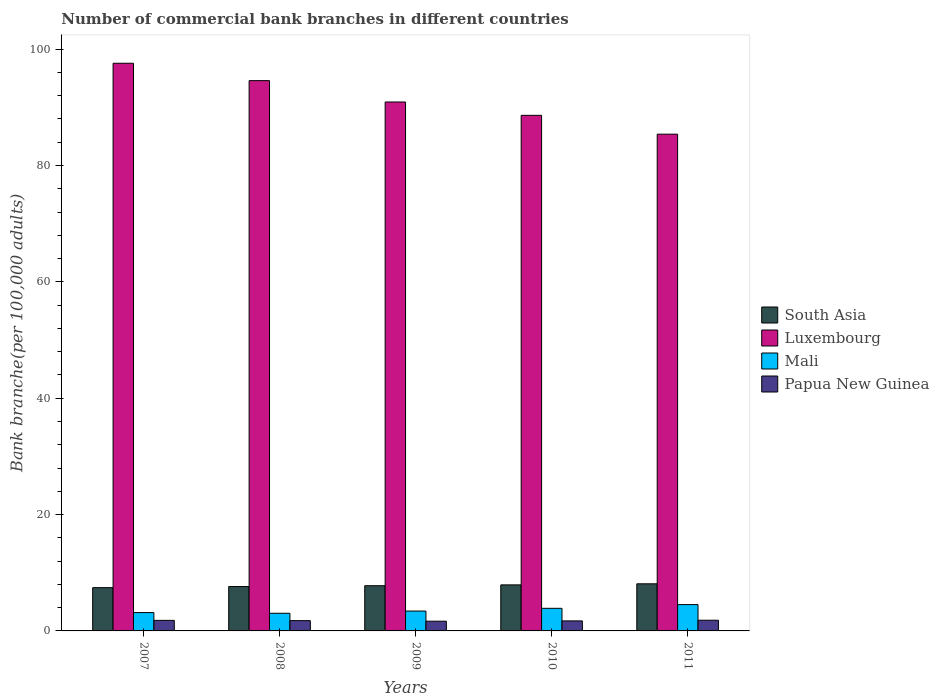How many groups of bars are there?
Make the answer very short. 5. Are the number of bars on each tick of the X-axis equal?
Your answer should be compact. Yes. How many bars are there on the 4th tick from the left?
Ensure brevity in your answer.  4. What is the number of commercial bank branches in Papua New Guinea in 2009?
Provide a succinct answer. 1.67. Across all years, what is the maximum number of commercial bank branches in Mali?
Provide a succinct answer. 4.52. Across all years, what is the minimum number of commercial bank branches in Mali?
Your response must be concise. 3.03. In which year was the number of commercial bank branches in Papua New Guinea maximum?
Your answer should be compact. 2011. In which year was the number of commercial bank branches in Mali minimum?
Make the answer very short. 2008. What is the total number of commercial bank branches in Mali in the graph?
Offer a very short reply. 18.01. What is the difference between the number of commercial bank branches in South Asia in 2008 and that in 2010?
Provide a succinct answer. -0.29. What is the difference between the number of commercial bank branches in Papua New Guinea in 2007 and the number of commercial bank branches in Mali in 2008?
Offer a very short reply. -1.22. What is the average number of commercial bank branches in Luxembourg per year?
Offer a terse response. 91.42. In the year 2009, what is the difference between the number of commercial bank branches in South Asia and number of commercial bank branches in Mali?
Keep it short and to the point. 4.36. In how many years, is the number of commercial bank branches in Luxembourg greater than 52?
Your answer should be compact. 5. What is the ratio of the number of commercial bank branches in South Asia in 2007 to that in 2009?
Your response must be concise. 0.96. Is the difference between the number of commercial bank branches in South Asia in 2007 and 2010 greater than the difference between the number of commercial bank branches in Mali in 2007 and 2010?
Keep it short and to the point. Yes. What is the difference between the highest and the second highest number of commercial bank branches in Luxembourg?
Offer a very short reply. 2.99. What is the difference between the highest and the lowest number of commercial bank branches in South Asia?
Ensure brevity in your answer.  0.66. What does the 4th bar from the left in 2008 represents?
Make the answer very short. Papua New Guinea. What does the 3rd bar from the right in 2010 represents?
Ensure brevity in your answer.  Luxembourg. How many bars are there?
Provide a short and direct response. 20. Does the graph contain any zero values?
Give a very brief answer. No. How are the legend labels stacked?
Provide a short and direct response. Vertical. What is the title of the graph?
Give a very brief answer. Number of commercial bank branches in different countries. What is the label or title of the X-axis?
Offer a terse response. Years. What is the label or title of the Y-axis?
Ensure brevity in your answer.  Bank branche(per 100,0 adults). What is the Bank branche(per 100,000 adults) in South Asia in 2007?
Provide a succinct answer. 7.44. What is the Bank branche(per 100,000 adults) of Luxembourg in 2007?
Ensure brevity in your answer.  97.57. What is the Bank branche(per 100,000 adults) in Mali in 2007?
Keep it short and to the point. 3.15. What is the Bank branche(per 100,000 adults) of Papua New Guinea in 2007?
Your answer should be compact. 1.81. What is the Bank branche(per 100,000 adults) in South Asia in 2008?
Your answer should be very brief. 7.63. What is the Bank branche(per 100,000 adults) in Luxembourg in 2008?
Provide a short and direct response. 94.59. What is the Bank branche(per 100,000 adults) in Mali in 2008?
Offer a terse response. 3.03. What is the Bank branche(per 100,000 adults) in Papua New Guinea in 2008?
Make the answer very short. 1.77. What is the Bank branche(per 100,000 adults) in South Asia in 2009?
Your response must be concise. 7.77. What is the Bank branche(per 100,000 adults) in Luxembourg in 2009?
Provide a short and direct response. 90.92. What is the Bank branche(per 100,000 adults) of Mali in 2009?
Make the answer very short. 3.42. What is the Bank branche(per 100,000 adults) in Papua New Guinea in 2009?
Ensure brevity in your answer.  1.67. What is the Bank branche(per 100,000 adults) in South Asia in 2010?
Make the answer very short. 7.91. What is the Bank branche(per 100,000 adults) in Luxembourg in 2010?
Give a very brief answer. 88.62. What is the Bank branche(per 100,000 adults) of Mali in 2010?
Your answer should be very brief. 3.88. What is the Bank branche(per 100,000 adults) of Papua New Guinea in 2010?
Give a very brief answer. 1.72. What is the Bank branche(per 100,000 adults) in South Asia in 2011?
Give a very brief answer. 8.1. What is the Bank branche(per 100,000 adults) of Luxembourg in 2011?
Make the answer very short. 85.38. What is the Bank branche(per 100,000 adults) of Mali in 2011?
Your answer should be compact. 4.52. What is the Bank branche(per 100,000 adults) of Papua New Guinea in 2011?
Your answer should be very brief. 1.84. Across all years, what is the maximum Bank branche(per 100,000 adults) in South Asia?
Make the answer very short. 8.1. Across all years, what is the maximum Bank branche(per 100,000 adults) in Luxembourg?
Offer a terse response. 97.57. Across all years, what is the maximum Bank branche(per 100,000 adults) of Mali?
Ensure brevity in your answer.  4.52. Across all years, what is the maximum Bank branche(per 100,000 adults) in Papua New Guinea?
Your response must be concise. 1.84. Across all years, what is the minimum Bank branche(per 100,000 adults) of South Asia?
Your answer should be compact. 7.44. Across all years, what is the minimum Bank branche(per 100,000 adults) of Luxembourg?
Give a very brief answer. 85.38. Across all years, what is the minimum Bank branche(per 100,000 adults) of Mali?
Provide a succinct answer. 3.03. Across all years, what is the minimum Bank branche(per 100,000 adults) of Papua New Guinea?
Make the answer very short. 1.67. What is the total Bank branche(per 100,000 adults) of South Asia in the graph?
Keep it short and to the point. 38.85. What is the total Bank branche(per 100,000 adults) of Luxembourg in the graph?
Give a very brief answer. 457.08. What is the total Bank branche(per 100,000 adults) in Mali in the graph?
Your response must be concise. 18.01. What is the total Bank branche(per 100,000 adults) of Papua New Guinea in the graph?
Your answer should be compact. 8.82. What is the difference between the Bank branche(per 100,000 adults) of South Asia in 2007 and that in 2008?
Your answer should be compact. -0.19. What is the difference between the Bank branche(per 100,000 adults) in Luxembourg in 2007 and that in 2008?
Your answer should be very brief. 2.99. What is the difference between the Bank branche(per 100,000 adults) of Mali in 2007 and that in 2008?
Make the answer very short. 0.12. What is the difference between the Bank branche(per 100,000 adults) of Papua New Guinea in 2007 and that in 2008?
Offer a terse response. 0.05. What is the difference between the Bank branche(per 100,000 adults) in South Asia in 2007 and that in 2009?
Keep it short and to the point. -0.33. What is the difference between the Bank branche(per 100,000 adults) of Luxembourg in 2007 and that in 2009?
Offer a terse response. 6.66. What is the difference between the Bank branche(per 100,000 adults) in Mali in 2007 and that in 2009?
Make the answer very short. -0.26. What is the difference between the Bank branche(per 100,000 adults) in Papua New Guinea in 2007 and that in 2009?
Provide a succinct answer. 0.14. What is the difference between the Bank branche(per 100,000 adults) of South Asia in 2007 and that in 2010?
Make the answer very short. -0.48. What is the difference between the Bank branche(per 100,000 adults) in Luxembourg in 2007 and that in 2010?
Ensure brevity in your answer.  8.95. What is the difference between the Bank branche(per 100,000 adults) of Mali in 2007 and that in 2010?
Your answer should be compact. -0.73. What is the difference between the Bank branche(per 100,000 adults) of Papua New Guinea in 2007 and that in 2010?
Your response must be concise. 0.09. What is the difference between the Bank branche(per 100,000 adults) of South Asia in 2007 and that in 2011?
Offer a very short reply. -0.66. What is the difference between the Bank branche(per 100,000 adults) of Luxembourg in 2007 and that in 2011?
Ensure brevity in your answer.  12.19. What is the difference between the Bank branche(per 100,000 adults) of Mali in 2007 and that in 2011?
Offer a very short reply. -1.37. What is the difference between the Bank branche(per 100,000 adults) in Papua New Guinea in 2007 and that in 2011?
Provide a short and direct response. -0.02. What is the difference between the Bank branche(per 100,000 adults) in South Asia in 2008 and that in 2009?
Provide a short and direct response. -0.14. What is the difference between the Bank branche(per 100,000 adults) of Luxembourg in 2008 and that in 2009?
Your answer should be very brief. 3.67. What is the difference between the Bank branche(per 100,000 adults) of Mali in 2008 and that in 2009?
Ensure brevity in your answer.  -0.38. What is the difference between the Bank branche(per 100,000 adults) of Papua New Guinea in 2008 and that in 2009?
Ensure brevity in your answer.  0.1. What is the difference between the Bank branche(per 100,000 adults) in South Asia in 2008 and that in 2010?
Offer a very short reply. -0.29. What is the difference between the Bank branche(per 100,000 adults) of Luxembourg in 2008 and that in 2010?
Offer a very short reply. 5.97. What is the difference between the Bank branche(per 100,000 adults) of Mali in 2008 and that in 2010?
Offer a terse response. -0.85. What is the difference between the Bank branche(per 100,000 adults) in Papua New Guinea in 2008 and that in 2010?
Ensure brevity in your answer.  0.04. What is the difference between the Bank branche(per 100,000 adults) of South Asia in 2008 and that in 2011?
Provide a succinct answer. -0.47. What is the difference between the Bank branche(per 100,000 adults) in Luxembourg in 2008 and that in 2011?
Ensure brevity in your answer.  9.2. What is the difference between the Bank branche(per 100,000 adults) of Mali in 2008 and that in 2011?
Your answer should be very brief. -1.49. What is the difference between the Bank branche(per 100,000 adults) of Papua New Guinea in 2008 and that in 2011?
Offer a very short reply. -0.07. What is the difference between the Bank branche(per 100,000 adults) in South Asia in 2009 and that in 2010?
Your answer should be compact. -0.14. What is the difference between the Bank branche(per 100,000 adults) in Luxembourg in 2009 and that in 2010?
Your response must be concise. 2.29. What is the difference between the Bank branche(per 100,000 adults) in Mali in 2009 and that in 2010?
Ensure brevity in your answer.  -0.47. What is the difference between the Bank branche(per 100,000 adults) of Papua New Guinea in 2009 and that in 2010?
Make the answer very short. -0.05. What is the difference between the Bank branche(per 100,000 adults) of South Asia in 2009 and that in 2011?
Make the answer very short. -0.33. What is the difference between the Bank branche(per 100,000 adults) of Luxembourg in 2009 and that in 2011?
Offer a very short reply. 5.53. What is the difference between the Bank branche(per 100,000 adults) in Mali in 2009 and that in 2011?
Your response must be concise. -1.11. What is the difference between the Bank branche(per 100,000 adults) of Papua New Guinea in 2009 and that in 2011?
Offer a terse response. -0.17. What is the difference between the Bank branche(per 100,000 adults) in South Asia in 2010 and that in 2011?
Ensure brevity in your answer.  -0.18. What is the difference between the Bank branche(per 100,000 adults) of Luxembourg in 2010 and that in 2011?
Provide a short and direct response. 3.24. What is the difference between the Bank branche(per 100,000 adults) in Mali in 2010 and that in 2011?
Give a very brief answer. -0.64. What is the difference between the Bank branche(per 100,000 adults) in Papua New Guinea in 2010 and that in 2011?
Provide a succinct answer. -0.12. What is the difference between the Bank branche(per 100,000 adults) in South Asia in 2007 and the Bank branche(per 100,000 adults) in Luxembourg in 2008?
Ensure brevity in your answer.  -87.15. What is the difference between the Bank branche(per 100,000 adults) of South Asia in 2007 and the Bank branche(per 100,000 adults) of Mali in 2008?
Provide a succinct answer. 4.4. What is the difference between the Bank branche(per 100,000 adults) of South Asia in 2007 and the Bank branche(per 100,000 adults) of Papua New Guinea in 2008?
Make the answer very short. 5.67. What is the difference between the Bank branche(per 100,000 adults) of Luxembourg in 2007 and the Bank branche(per 100,000 adults) of Mali in 2008?
Your answer should be compact. 94.54. What is the difference between the Bank branche(per 100,000 adults) in Luxembourg in 2007 and the Bank branche(per 100,000 adults) in Papua New Guinea in 2008?
Give a very brief answer. 95.81. What is the difference between the Bank branche(per 100,000 adults) of Mali in 2007 and the Bank branche(per 100,000 adults) of Papua New Guinea in 2008?
Provide a succinct answer. 1.39. What is the difference between the Bank branche(per 100,000 adults) of South Asia in 2007 and the Bank branche(per 100,000 adults) of Luxembourg in 2009?
Offer a terse response. -83.48. What is the difference between the Bank branche(per 100,000 adults) of South Asia in 2007 and the Bank branche(per 100,000 adults) of Mali in 2009?
Provide a succinct answer. 4.02. What is the difference between the Bank branche(per 100,000 adults) of South Asia in 2007 and the Bank branche(per 100,000 adults) of Papua New Guinea in 2009?
Make the answer very short. 5.77. What is the difference between the Bank branche(per 100,000 adults) in Luxembourg in 2007 and the Bank branche(per 100,000 adults) in Mali in 2009?
Keep it short and to the point. 94.16. What is the difference between the Bank branche(per 100,000 adults) in Luxembourg in 2007 and the Bank branche(per 100,000 adults) in Papua New Guinea in 2009?
Make the answer very short. 95.9. What is the difference between the Bank branche(per 100,000 adults) in Mali in 2007 and the Bank branche(per 100,000 adults) in Papua New Guinea in 2009?
Your response must be concise. 1.48. What is the difference between the Bank branche(per 100,000 adults) in South Asia in 2007 and the Bank branche(per 100,000 adults) in Luxembourg in 2010?
Ensure brevity in your answer.  -81.18. What is the difference between the Bank branche(per 100,000 adults) in South Asia in 2007 and the Bank branche(per 100,000 adults) in Mali in 2010?
Offer a terse response. 3.55. What is the difference between the Bank branche(per 100,000 adults) of South Asia in 2007 and the Bank branche(per 100,000 adults) of Papua New Guinea in 2010?
Make the answer very short. 5.71. What is the difference between the Bank branche(per 100,000 adults) of Luxembourg in 2007 and the Bank branche(per 100,000 adults) of Mali in 2010?
Offer a very short reply. 93.69. What is the difference between the Bank branche(per 100,000 adults) in Luxembourg in 2007 and the Bank branche(per 100,000 adults) in Papua New Guinea in 2010?
Provide a short and direct response. 95.85. What is the difference between the Bank branche(per 100,000 adults) in Mali in 2007 and the Bank branche(per 100,000 adults) in Papua New Guinea in 2010?
Offer a terse response. 1.43. What is the difference between the Bank branche(per 100,000 adults) in South Asia in 2007 and the Bank branche(per 100,000 adults) in Luxembourg in 2011?
Ensure brevity in your answer.  -77.95. What is the difference between the Bank branche(per 100,000 adults) in South Asia in 2007 and the Bank branche(per 100,000 adults) in Mali in 2011?
Keep it short and to the point. 2.91. What is the difference between the Bank branche(per 100,000 adults) in South Asia in 2007 and the Bank branche(per 100,000 adults) in Papua New Guinea in 2011?
Make the answer very short. 5.6. What is the difference between the Bank branche(per 100,000 adults) in Luxembourg in 2007 and the Bank branche(per 100,000 adults) in Mali in 2011?
Offer a very short reply. 93.05. What is the difference between the Bank branche(per 100,000 adults) of Luxembourg in 2007 and the Bank branche(per 100,000 adults) of Papua New Guinea in 2011?
Ensure brevity in your answer.  95.73. What is the difference between the Bank branche(per 100,000 adults) in Mali in 2007 and the Bank branche(per 100,000 adults) in Papua New Guinea in 2011?
Ensure brevity in your answer.  1.32. What is the difference between the Bank branche(per 100,000 adults) of South Asia in 2008 and the Bank branche(per 100,000 adults) of Luxembourg in 2009?
Your response must be concise. -83.29. What is the difference between the Bank branche(per 100,000 adults) of South Asia in 2008 and the Bank branche(per 100,000 adults) of Mali in 2009?
Ensure brevity in your answer.  4.21. What is the difference between the Bank branche(per 100,000 adults) in South Asia in 2008 and the Bank branche(per 100,000 adults) in Papua New Guinea in 2009?
Offer a very short reply. 5.96. What is the difference between the Bank branche(per 100,000 adults) of Luxembourg in 2008 and the Bank branche(per 100,000 adults) of Mali in 2009?
Offer a terse response. 91.17. What is the difference between the Bank branche(per 100,000 adults) in Luxembourg in 2008 and the Bank branche(per 100,000 adults) in Papua New Guinea in 2009?
Give a very brief answer. 92.92. What is the difference between the Bank branche(per 100,000 adults) of Mali in 2008 and the Bank branche(per 100,000 adults) of Papua New Guinea in 2009?
Your answer should be compact. 1.36. What is the difference between the Bank branche(per 100,000 adults) of South Asia in 2008 and the Bank branche(per 100,000 adults) of Luxembourg in 2010?
Give a very brief answer. -80.99. What is the difference between the Bank branche(per 100,000 adults) of South Asia in 2008 and the Bank branche(per 100,000 adults) of Mali in 2010?
Provide a succinct answer. 3.74. What is the difference between the Bank branche(per 100,000 adults) of South Asia in 2008 and the Bank branche(per 100,000 adults) of Papua New Guinea in 2010?
Offer a terse response. 5.91. What is the difference between the Bank branche(per 100,000 adults) in Luxembourg in 2008 and the Bank branche(per 100,000 adults) in Mali in 2010?
Give a very brief answer. 90.7. What is the difference between the Bank branche(per 100,000 adults) in Luxembourg in 2008 and the Bank branche(per 100,000 adults) in Papua New Guinea in 2010?
Provide a short and direct response. 92.86. What is the difference between the Bank branche(per 100,000 adults) of Mali in 2008 and the Bank branche(per 100,000 adults) of Papua New Guinea in 2010?
Your answer should be compact. 1.31. What is the difference between the Bank branche(per 100,000 adults) in South Asia in 2008 and the Bank branche(per 100,000 adults) in Luxembourg in 2011?
Offer a terse response. -77.76. What is the difference between the Bank branche(per 100,000 adults) in South Asia in 2008 and the Bank branche(per 100,000 adults) in Mali in 2011?
Your answer should be very brief. 3.1. What is the difference between the Bank branche(per 100,000 adults) of South Asia in 2008 and the Bank branche(per 100,000 adults) of Papua New Guinea in 2011?
Give a very brief answer. 5.79. What is the difference between the Bank branche(per 100,000 adults) of Luxembourg in 2008 and the Bank branche(per 100,000 adults) of Mali in 2011?
Give a very brief answer. 90.06. What is the difference between the Bank branche(per 100,000 adults) of Luxembourg in 2008 and the Bank branche(per 100,000 adults) of Papua New Guinea in 2011?
Ensure brevity in your answer.  92.75. What is the difference between the Bank branche(per 100,000 adults) in Mali in 2008 and the Bank branche(per 100,000 adults) in Papua New Guinea in 2011?
Provide a short and direct response. 1.19. What is the difference between the Bank branche(per 100,000 adults) of South Asia in 2009 and the Bank branche(per 100,000 adults) of Luxembourg in 2010?
Keep it short and to the point. -80.85. What is the difference between the Bank branche(per 100,000 adults) of South Asia in 2009 and the Bank branche(per 100,000 adults) of Mali in 2010?
Provide a succinct answer. 3.89. What is the difference between the Bank branche(per 100,000 adults) of South Asia in 2009 and the Bank branche(per 100,000 adults) of Papua New Guinea in 2010?
Your answer should be compact. 6.05. What is the difference between the Bank branche(per 100,000 adults) of Luxembourg in 2009 and the Bank branche(per 100,000 adults) of Mali in 2010?
Keep it short and to the point. 87.03. What is the difference between the Bank branche(per 100,000 adults) of Luxembourg in 2009 and the Bank branche(per 100,000 adults) of Papua New Guinea in 2010?
Keep it short and to the point. 89.19. What is the difference between the Bank branche(per 100,000 adults) in Mali in 2009 and the Bank branche(per 100,000 adults) in Papua New Guinea in 2010?
Ensure brevity in your answer.  1.69. What is the difference between the Bank branche(per 100,000 adults) in South Asia in 2009 and the Bank branche(per 100,000 adults) in Luxembourg in 2011?
Offer a terse response. -77.61. What is the difference between the Bank branche(per 100,000 adults) in South Asia in 2009 and the Bank branche(per 100,000 adults) in Mali in 2011?
Your response must be concise. 3.25. What is the difference between the Bank branche(per 100,000 adults) of South Asia in 2009 and the Bank branche(per 100,000 adults) of Papua New Guinea in 2011?
Provide a short and direct response. 5.93. What is the difference between the Bank branche(per 100,000 adults) in Luxembourg in 2009 and the Bank branche(per 100,000 adults) in Mali in 2011?
Provide a succinct answer. 86.39. What is the difference between the Bank branche(per 100,000 adults) of Luxembourg in 2009 and the Bank branche(per 100,000 adults) of Papua New Guinea in 2011?
Keep it short and to the point. 89.08. What is the difference between the Bank branche(per 100,000 adults) in Mali in 2009 and the Bank branche(per 100,000 adults) in Papua New Guinea in 2011?
Make the answer very short. 1.58. What is the difference between the Bank branche(per 100,000 adults) in South Asia in 2010 and the Bank branche(per 100,000 adults) in Luxembourg in 2011?
Your answer should be compact. -77.47. What is the difference between the Bank branche(per 100,000 adults) in South Asia in 2010 and the Bank branche(per 100,000 adults) in Mali in 2011?
Your answer should be very brief. 3.39. What is the difference between the Bank branche(per 100,000 adults) in South Asia in 2010 and the Bank branche(per 100,000 adults) in Papua New Guinea in 2011?
Provide a short and direct response. 6.08. What is the difference between the Bank branche(per 100,000 adults) of Luxembourg in 2010 and the Bank branche(per 100,000 adults) of Mali in 2011?
Ensure brevity in your answer.  84.1. What is the difference between the Bank branche(per 100,000 adults) of Luxembourg in 2010 and the Bank branche(per 100,000 adults) of Papua New Guinea in 2011?
Ensure brevity in your answer.  86.78. What is the difference between the Bank branche(per 100,000 adults) in Mali in 2010 and the Bank branche(per 100,000 adults) in Papua New Guinea in 2011?
Your answer should be very brief. 2.05. What is the average Bank branche(per 100,000 adults) of South Asia per year?
Your answer should be very brief. 7.77. What is the average Bank branche(per 100,000 adults) in Luxembourg per year?
Offer a terse response. 91.42. What is the average Bank branche(per 100,000 adults) in Mali per year?
Keep it short and to the point. 3.6. What is the average Bank branche(per 100,000 adults) of Papua New Guinea per year?
Your answer should be very brief. 1.76. In the year 2007, what is the difference between the Bank branche(per 100,000 adults) of South Asia and Bank branche(per 100,000 adults) of Luxembourg?
Your answer should be very brief. -90.14. In the year 2007, what is the difference between the Bank branche(per 100,000 adults) in South Asia and Bank branche(per 100,000 adults) in Mali?
Provide a short and direct response. 4.28. In the year 2007, what is the difference between the Bank branche(per 100,000 adults) of South Asia and Bank branche(per 100,000 adults) of Papua New Guinea?
Keep it short and to the point. 5.62. In the year 2007, what is the difference between the Bank branche(per 100,000 adults) in Luxembourg and Bank branche(per 100,000 adults) in Mali?
Make the answer very short. 94.42. In the year 2007, what is the difference between the Bank branche(per 100,000 adults) in Luxembourg and Bank branche(per 100,000 adults) in Papua New Guinea?
Offer a terse response. 95.76. In the year 2007, what is the difference between the Bank branche(per 100,000 adults) in Mali and Bank branche(per 100,000 adults) in Papua New Guinea?
Offer a terse response. 1.34. In the year 2008, what is the difference between the Bank branche(per 100,000 adults) in South Asia and Bank branche(per 100,000 adults) in Luxembourg?
Keep it short and to the point. -86.96. In the year 2008, what is the difference between the Bank branche(per 100,000 adults) in South Asia and Bank branche(per 100,000 adults) in Mali?
Keep it short and to the point. 4.6. In the year 2008, what is the difference between the Bank branche(per 100,000 adults) of South Asia and Bank branche(per 100,000 adults) of Papua New Guinea?
Keep it short and to the point. 5.86. In the year 2008, what is the difference between the Bank branche(per 100,000 adults) of Luxembourg and Bank branche(per 100,000 adults) of Mali?
Your answer should be compact. 91.55. In the year 2008, what is the difference between the Bank branche(per 100,000 adults) in Luxembourg and Bank branche(per 100,000 adults) in Papua New Guinea?
Give a very brief answer. 92.82. In the year 2008, what is the difference between the Bank branche(per 100,000 adults) in Mali and Bank branche(per 100,000 adults) in Papua New Guinea?
Give a very brief answer. 1.27. In the year 2009, what is the difference between the Bank branche(per 100,000 adults) of South Asia and Bank branche(per 100,000 adults) of Luxembourg?
Give a very brief answer. -83.15. In the year 2009, what is the difference between the Bank branche(per 100,000 adults) of South Asia and Bank branche(per 100,000 adults) of Mali?
Your answer should be very brief. 4.36. In the year 2009, what is the difference between the Bank branche(per 100,000 adults) in South Asia and Bank branche(per 100,000 adults) in Papua New Guinea?
Offer a terse response. 6.1. In the year 2009, what is the difference between the Bank branche(per 100,000 adults) of Luxembourg and Bank branche(per 100,000 adults) of Mali?
Give a very brief answer. 87.5. In the year 2009, what is the difference between the Bank branche(per 100,000 adults) of Luxembourg and Bank branche(per 100,000 adults) of Papua New Guinea?
Your answer should be very brief. 89.24. In the year 2009, what is the difference between the Bank branche(per 100,000 adults) of Mali and Bank branche(per 100,000 adults) of Papua New Guinea?
Your answer should be very brief. 1.74. In the year 2010, what is the difference between the Bank branche(per 100,000 adults) in South Asia and Bank branche(per 100,000 adults) in Luxembourg?
Give a very brief answer. -80.71. In the year 2010, what is the difference between the Bank branche(per 100,000 adults) in South Asia and Bank branche(per 100,000 adults) in Mali?
Make the answer very short. 4.03. In the year 2010, what is the difference between the Bank branche(per 100,000 adults) of South Asia and Bank branche(per 100,000 adults) of Papua New Guinea?
Your answer should be compact. 6.19. In the year 2010, what is the difference between the Bank branche(per 100,000 adults) in Luxembourg and Bank branche(per 100,000 adults) in Mali?
Provide a short and direct response. 84.74. In the year 2010, what is the difference between the Bank branche(per 100,000 adults) in Luxembourg and Bank branche(per 100,000 adults) in Papua New Guinea?
Offer a very short reply. 86.9. In the year 2010, what is the difference between the Bank branche(per 100,000 adults) of Mali and Bank branche(per 100,000 adults) of Papua New Guinea?
Your answer should be very brief. 2.16. In the year 2011, what is the difference between the Bank branche(per 100,000 adults) of South Asia and Bank branche(per 100,000 adults) of Luxembourg?
Ensure brevity in your answer.  -77.29. In the year 2011, what is the difference between the Bank branche(per 100,000 adults) in South Asia and Bank branche(per 100,000 adults) in Mali?
Offer a terse response. 3.57. In the year 2011, what is the difference between the Bank branche(per 100,000 adults) of South Asia and Bank branche(per 100,000 adults) of Papua New Guinea?
Ensure brevity in your answer.  6.26. In the year 2011, what is the difference between the Bank branche(per 100,000 adults) in Luxembourg and Bank branche(per 100,000 adults) in Mali?
Make the answer very short. 80.86. In the year 2011, what is the difference between the Bank branche(per 100,000 adults) of Luxembourg and Bank branche(per 100,000 adults) of Papua New Guinea?
Keep it short and to the point. 83.55. In the year 2011, what is the difference between the Bank branche(per 100,000 adults) of Mali and Bank branche(per 100,000 adults) of Papua New Guinea?
Your response must be concise. 2.69. What is the ratio of the Bank branche(per 100,000 adults) of South Asia in 2007 to that in 2008?
Provide a succinct answer. 0.97. What is the ratio of the Bank branche(per 100,000 adults) in Luxembourg in 2007 to that in 2008?
Your response must be concise. 1.03. What is the ratio of the Bank branche(per 100,000 adults) in Mali in 2007 to that in 2008?
Offer a very short reply. 1.04. What is the ratio of the Bank branche(per 100,000 adults) in Papua New Guinea in 2007 to that in 2008?
Provide a short and direct response. 1.03. What is the ratio of the Bank branche(per 100,000 adults) of South Asia in 2007 to that in 2009?
Provide a succinct answer. 0.96. What is the ratio of the Bank branche(per 100,000 adults) of Luxembourg in 2007 to that in 2009?
Offer a terse response. 1.07. What is the ratio of the Bank branche(per 100,000 adults) of Mali in 2007 to that in 2009?
Make the answer very short. 0.92. What is the ratio of the Bank branche(per 100,000 adults) of Papua New Guinea in 2007 to that in 2009?
Give a very brief answer. 1.09. What is the ratio of the Bank branche(per 100,000 adults) in South Asia in 2007 to that in 2010?
Give a very brief answer. 0.94. What is the ratio of the Bank branche(per 100,000 adults) of Luxembourg in 2007 to that in 2010?
Provide a succinct answer. 1.1. What is the ratio of the Bank branche(per 100,000 adults) of Mali in 2007 to that in 2010?
Offer a very short reply. 0.81. What is the ratio of the Bank branche(per 100,000 adults) of Papua New Guinea in 2007 to that in 2010?
Make the answer very short. 1.05. What is the ratio of the Bank branche(per 100,000 adults) of South Asia in 2007 to that in 2011?
Offer a terse response. 0.92. What is the ratio of the Bank branche(per 100,000 adults) in Luxembourg in 2007 to that in 2011?
Provide a succinct answer. 1.14. What is the ratio of the Bank branche(per 100,000 adults) of Mali in 2007 to that in 2011?
Your answer should be compact. 0.7. What is the ratio of the Bank branche(per 100,000 adults) in Papua New Guinea in 2007 to that in 2011?
Your response must be concise. 0.99. What is the ratio of the Bank branche(per 100,000 adults) of South Asia in 2008 to that in 2009?
Your answer should be very brief. 0.98. What is the ratio of the Bank branche(per 100,000 adults) in Luxembourg in 2008 to that in 2009?
Your answer should be very brief. 1.04. What is the ratio of the Bank branche(per 100,000 adults) of Mali in 2008 to that in 2009?
Offer a very short reply. 0.89. What is the ratio of the Bank branche(per 100,000 adults) of Papua New Guinea in 2008 to that in 2009?
Provide a short and direct response. 1.06. What is the ratio of the Bank branche(per 100,000 adults) of South Asia in 2008 to that in 2010?
Keep it short and to the point. 0.96. What is the ratio of the Bank branche(per 100,000 adults) of Luxembourg in 2008 to that in 2010?
Provide a short and direct response. 1.07. What is the ratio of the Bank branche(per 100,000 adults) of Mali in 2008 to that in 2010?
Keep it short and to the point. 0.78. What is the ratio of the Bank branche(per 100,000 adults) of Papua New Guinea in 2008 to that in 2010?
Your response must be concise. 1.03. What is the ratio of the Bank branche(per 100,000 adults) of South Asia in 2008 to that in 2011?
Make the answer very short. 0.94. What is the ratio of the Bank branche(per 100,000 adults) in Luxembourg in 2008 to that in 2011?
Make the answer very short. 1.11. What is the ratio of the Bank branche(per 100,000 adults) of Mali in 2008 to that in 2011?
Your answer should be compact. 0.67. What is the ratio of the Bank branche(per 100,000 adults) in Papua New Guinea in 2008 to that in 2011?
Offer a very short reply. 0.96. What is the ratio of the Bank branche(per 100,000 adults) of South Asia in 2009 to that in 2010?
Your response must be concise. 0.98. What is the ratio of the Bank branche(per 100,000 adults) in Luxembourg in 2009 to that in 2010?
Offer a very short reply. 1.03. What is the ratio of the Bank branche(per 100,000 adults) in Mali in 2009 to that in 2010?
Make the answer very short. 0.88. What is the ratio of the Bank branche(per 100,000 adults) of Papua New Guinea in 2009 to that in 2010?
Your answer should be very brief. 0.97. What is the ratio of the Bank branche(per 100,000 adults) in South Asia in 2009 to that in 2011?
Offer a very short reply. 0.96. What is the ratio of the Bank branche(per 100,000 adults) in Luxembourg in 2009 to that in 2011?
Provide a succinct answer. 1.06. What is the ratio of the Bank branche(per 100,000 adults) in Mali in 2009 to that in 2011?
Your answer should be compact. 0.75. What is the ratio of the Bank branche(per 100,000 adults) in South Asia in 2010 to that in 2011?
Give a very brief answer. 0.98. What is the ratio of the Bank branche(per 100,000 adults) in Luxembourg in 2010 to that in 2011?
Provide a succinct answer. 1.04. What is the ratio of the Bank branche(per 100,000 adults) in Mali in 2010 to that in 2011?
Your response must be concise. 0.86. What is the ratio of the Bank branche(per 100,000 adults) in Papua New Guinea in 2010 to that in 2011?
Make the answer very short. 0.94. What is the difference between the highest and the second highest Bank branche(per 100,000 adults) of South Asia?
Make the answer very short. 0.18. What is the difference between the highest and the second highest Bank branche(per 100,000 adults) of Luxembourg?
Give a very brief answer. 2.99. What is the difference between the highest and the second highest Bank branche(per 100,000 adults) in Mali?
Ensure brevity in your answer.  0.64. What is the difference between the highest and the second highest Bank branche(per 100,000 adults) of Papua New Guinea?
Your answer should be very brief. 0.02. What is the difference between the highest and the lowest Bank branche(per 100,000 adults) of South Asia?
Your answer should be very brief. 0.66. What is the difference between the highest and the lowest Bank branche(per 100,000 adults) of Luxembourg?
Ensure brevity in your answer.  12.19. What is the difference between the highest and the lowest Bank branche(per 100,000 adults) in Mali?
Your answer should be compact. 1.49. What is the difference between the highest and the lowest Bank branche(per 100,000 adults) in Papua New Guinea?
Your answer should be very brief. 0.17. 